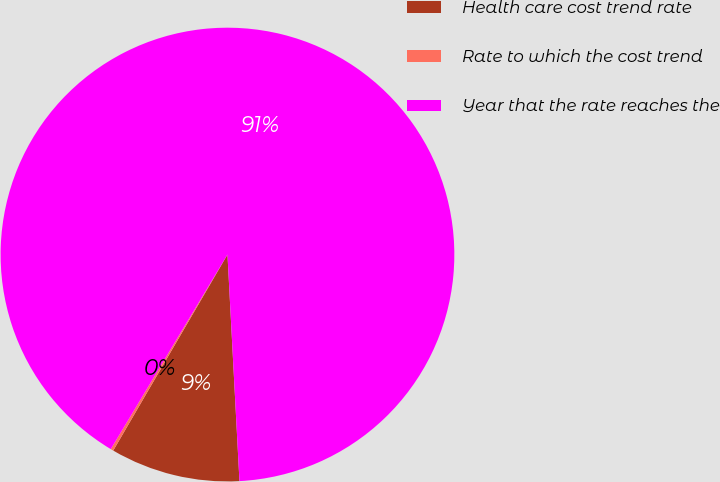Convert chart. <chart><loc_0><loc_0><loc_500><loc_500><pie_chart><fcel>Health care cost trend rate<fcel>Rate to which the cost trend<fcel>Year that the rate reaches the<nl><fcel>9.24%<fcel>0.2%<fcel>90.56%<nl></chart> 